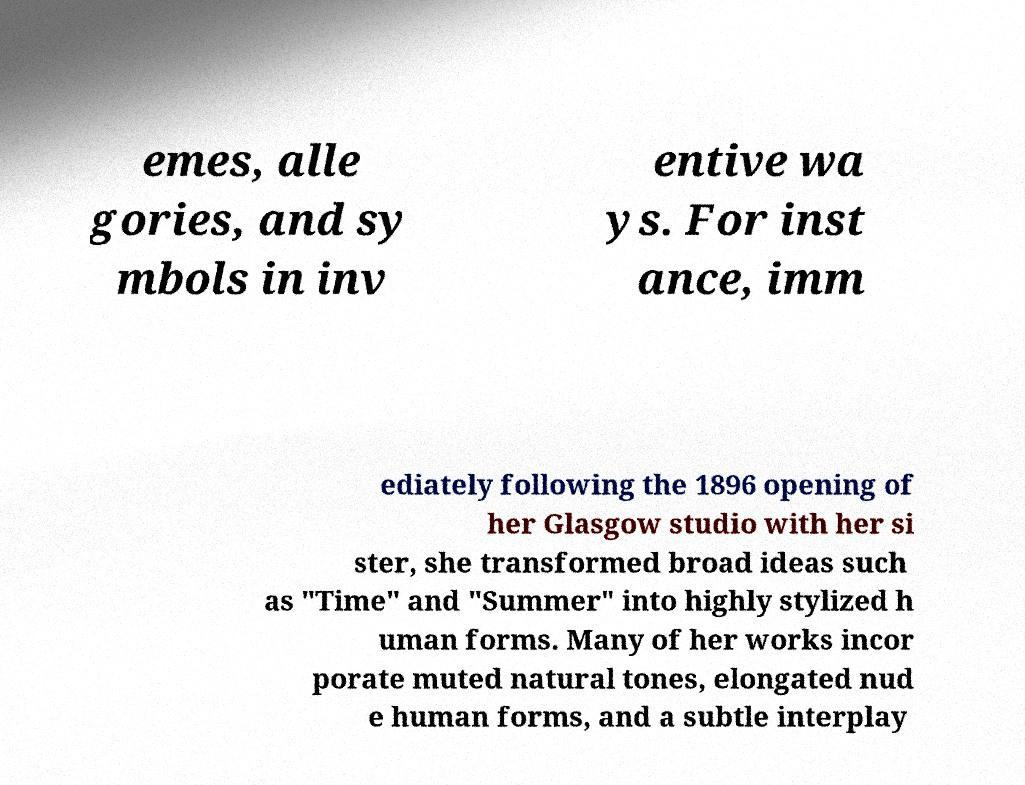Could you assist in decoding the text presented in this image and type it out clearly? emes, alle gories, and sy mbols in inv entive wa ys. For inst ance, imm ediately following the 1896 opening of her Glasgow studio with her si ster, she transformed broad ideas such as "Time" and "Summer" into highly stylized h uman forms. Many of her works incor porate muted natural tones, elongated nud e human forms, and a subtle interplay 